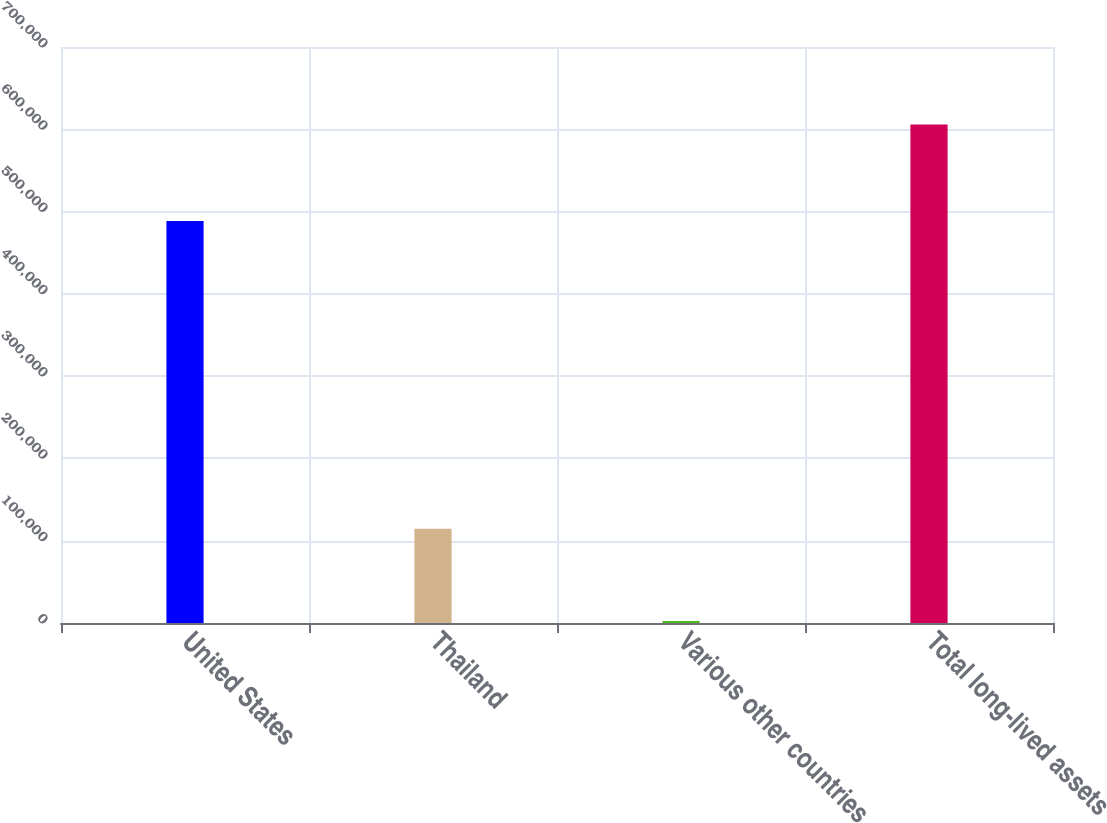Convert chart. <chart><loc_0><loc_0><loc_500><loc_500><bar_chart><fcel>United States<fcel>Thailand<fcel>Various other countries<fcel>Total long-lived assets<nl><fcel>488687<fcel>114560<fcel>2475<fcel>605722<nl></chart> 